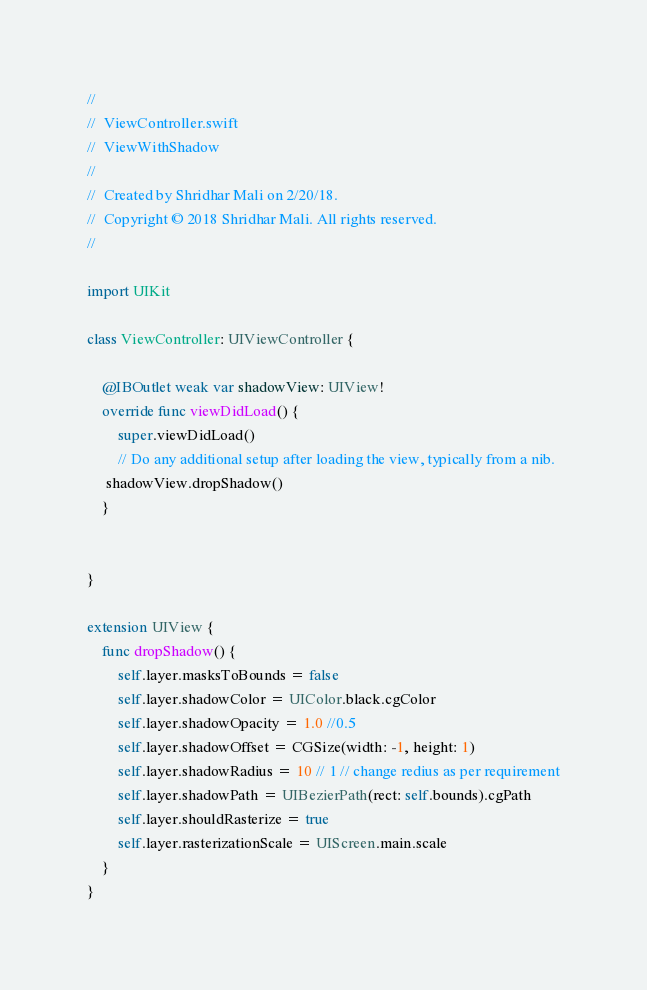<code> <loc_0><loc_0><loc_500><loc_500><_Swift_>//
//  ViewController.swift
//  ViewWithShadow
//
//  Created by Shridhar Mali on 2/20/18.
//  Copyright © 2018 Shridhar Mali. All rights reserved.
//

import UIKit

class ViewController: UIViewController {

    @IBOutlet weak var shadowView: UIView!
    override func viewDidLoad() {
        super.viewDidLoad()
        // Do any additional setup after loading the view, typically from a nib.
     shadowView.dropShadow()
    }


}

extension UIView {
    func dropShadow() {
        self.layer.masksToBounds = false
        self.layer.shadowColor = UIColor.black.cgColor
        self.layer.shadowOpacity = 1.0 //0.5
        self.layer.shadowOffset = CGSize(width: -1, height: 1)
        self.layer.shadowRadius = 10 // 1 // change redius as per requirement
        self.layer.shadowPath = UIBezierPath(rect: self.bounds).cgPath
        self.layer.shouldRasterize = true
        self.layer.rasterizationScale = UIScreen.main.scale
    }
}
</code> 